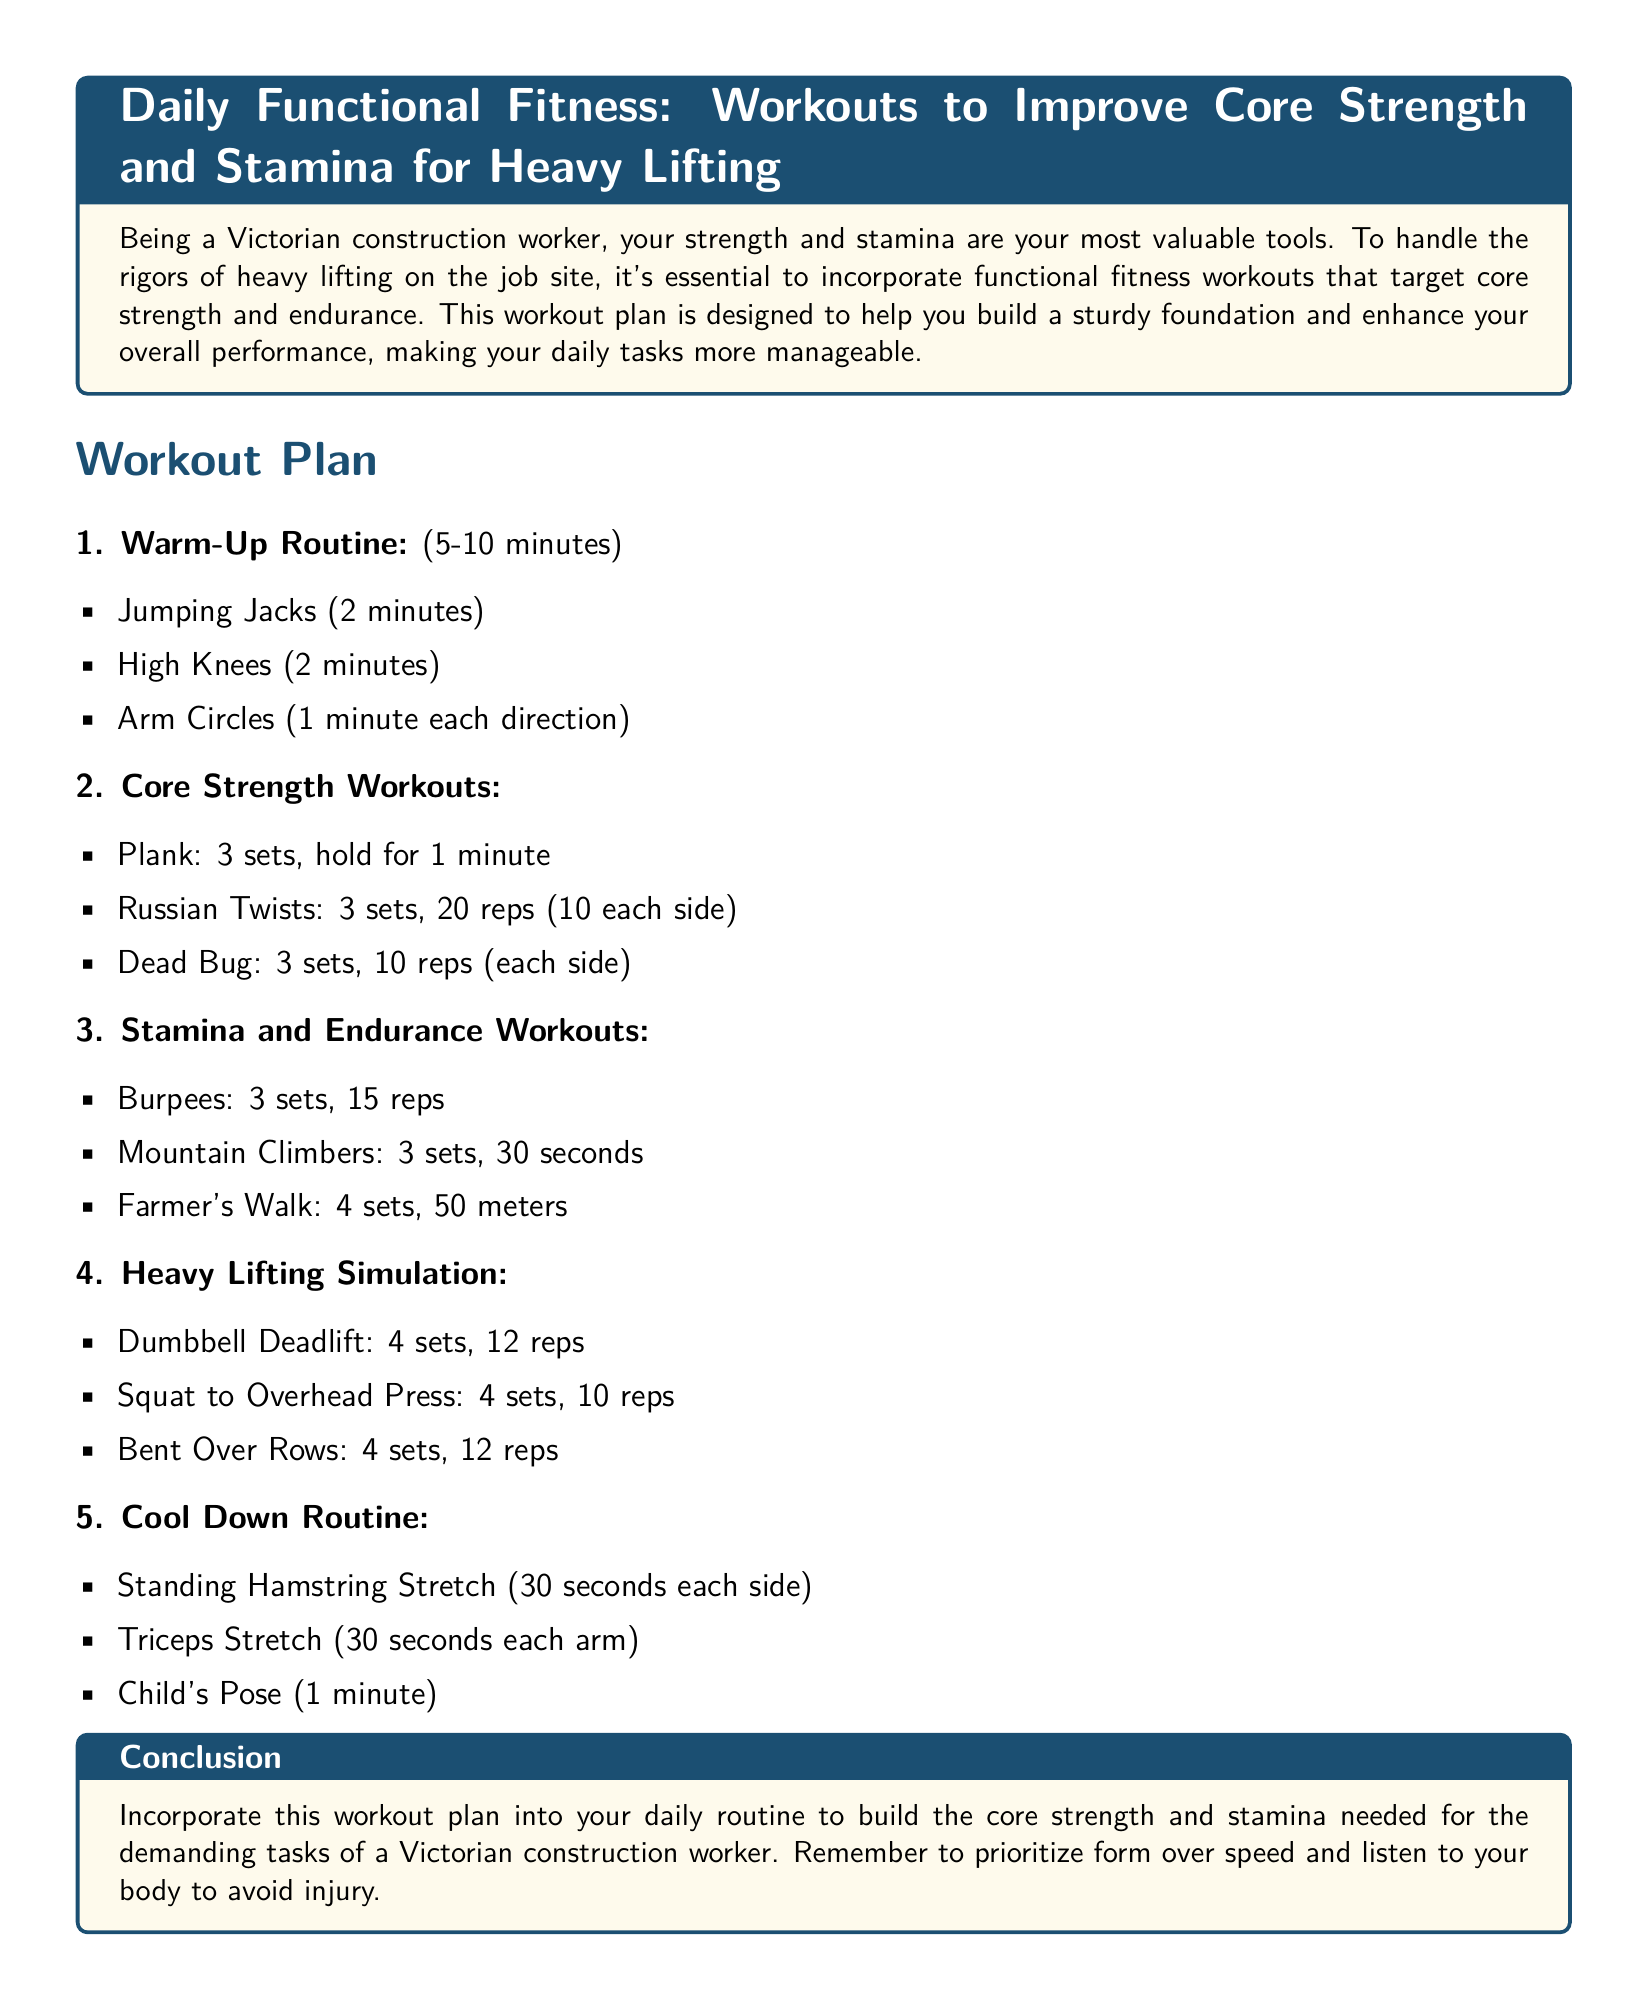what is the first exercise in the warm-up routine? The first exercise listed in the warm-up routine is Jumping Jacks.
Answer: Jumping Jacks how long does the Plank need to be held? The document specifies holding the Plank for 1 minute during the core strength workouts.
Answer: 1 minute how many sets are recommended for Russian Twists? The document states that 3 sets are recommended for Russian Twists in the core strength workouts.
Answer: 3 sets what is the total number of Burpees to be completed? The workout plan indicates 3 sets of 15 reps for Burpees, totaling 45 Burpees.
Answer: 45 what is the last exercise in the cool down routine? The last exercise listed in the cool down routine is Child's Pose.
Answer: Child's Pose which section follows the Core Strength Workouts in the plan? The section that follows the Core Strength Workouts is Stamina and Endurance Workouts.
Answer: Stamina and Endurance Workouts how many repetitions are recommended for Dumbbell Deadlifts? The plan recommends 12 repetitions for Dumbbell Deadlifts.
Answer: 12 reps what is the primary focus of the workout plan? The primary focus of the workout plan is to improve core strength and stamina for heavy lifting.
Answer: core strength and stamina 